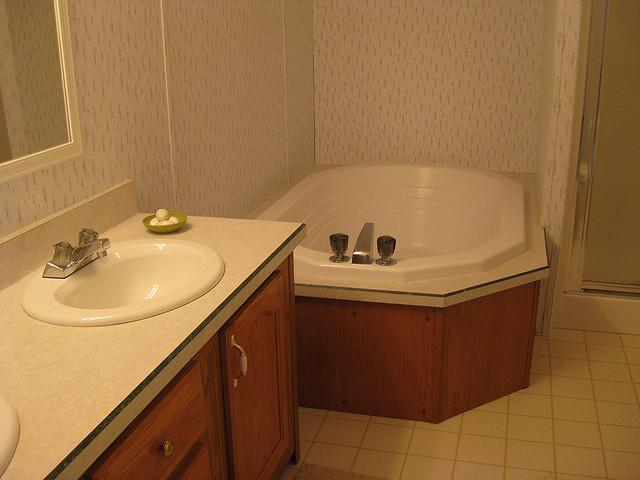What color is the sink and the bathtub?
Give a very brief answer. White. What color is the soap holder?
Give a very brief answer. Green. Are there any towels pictured?
Write a very short answer. No. What color are the bathroom tiles?
Give a very brief answer. White. Is this clean?
Keep it brief. Yes. What material are the cabinets made of?
Be succinct. Wood. 